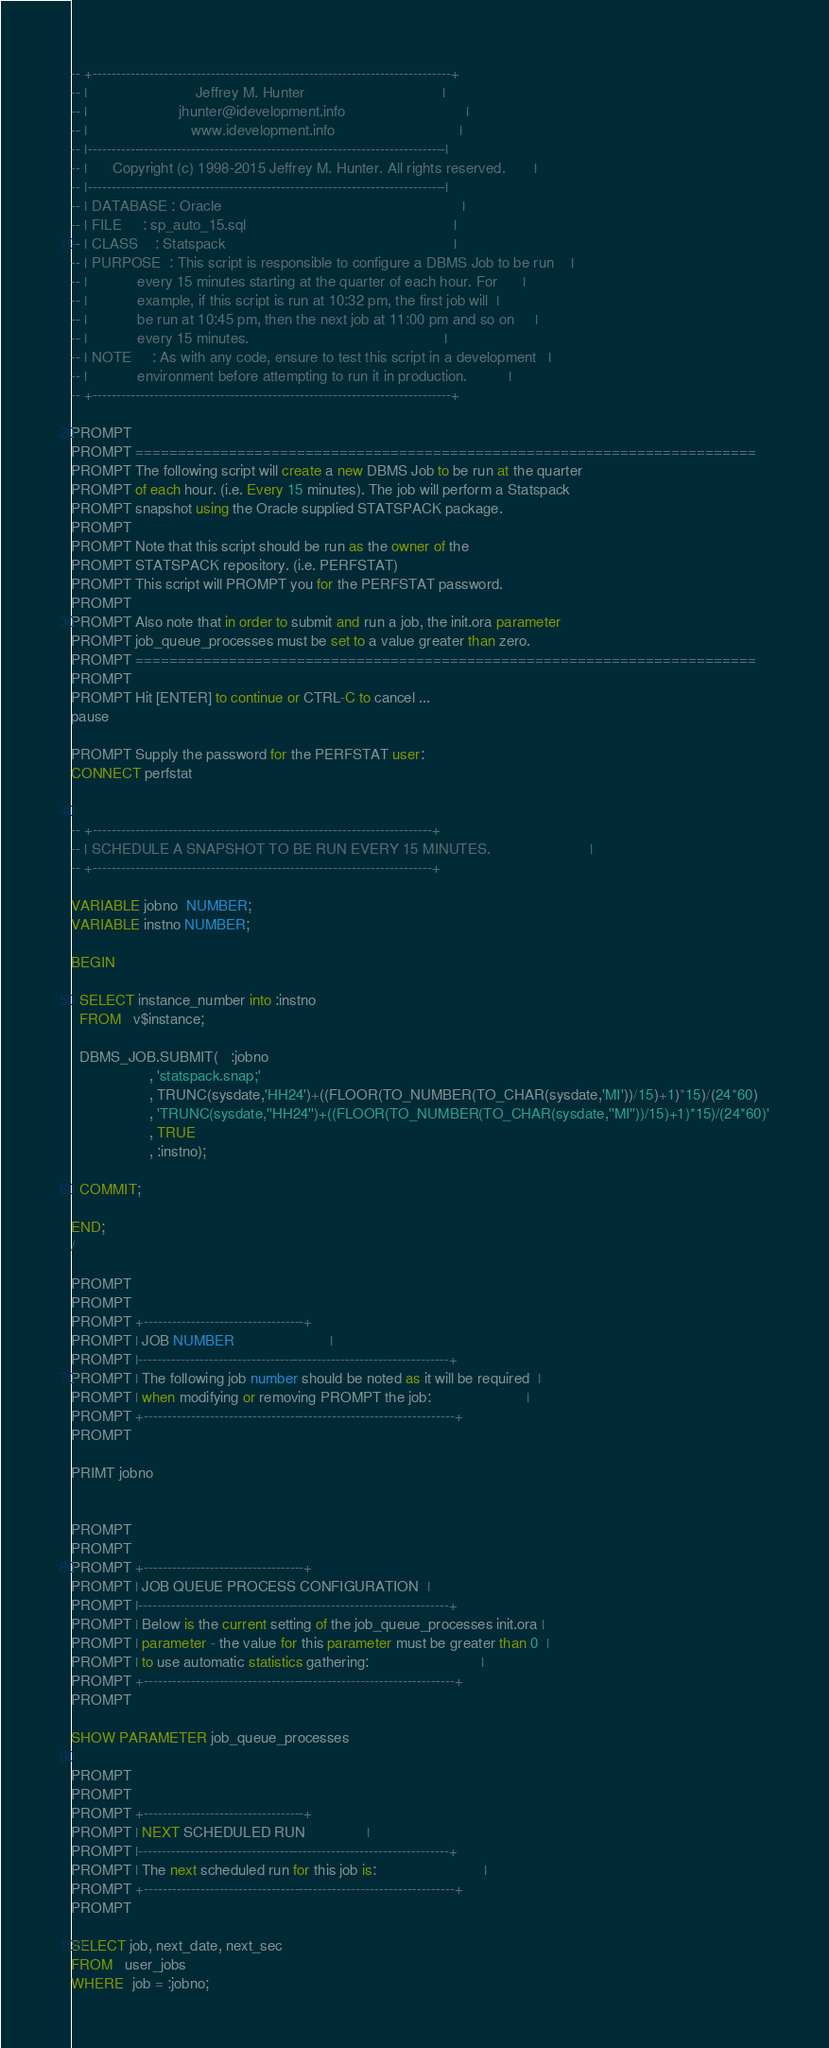<code> <loc_0><loc_0><loc_500><loc_500><_SQL_>-- +----------------------------------------------------------------------------+
-- |                          Jeffrey M. Hunter                                 |
-- |                      jhunter@idevelopment.info                             |
-- |                         www.idevelopment.info                              |
-- |----------------------------------------------------------------------------|
-- |      Copyright (c) 1998-2015 Jeffrey M. Hunter. All rights reserved.       |
-- |----------------------------------------------------------------------------|
-- | DATABASE : Oracle                                                          |
-- | FILE     : sp_auto_15.sql                                                  |
-- | CLASS    : Statspack                                                       |
-- | PURPOSE  : This script is responsible to configure a DBMS Job to be run    |
-- |            every 15 minutes starting at the quarter of each hour. For      |
-- |            example, if this script is run at 10:32 pm, the first job will  |
-- |            be run at 10:45 pm, then the next job at 11:00 pm and so on     |
-- |            every 15 minutes.                                               |
-- | NOTE     : As with any code, ensure to test this script in a development   |
-- |            environment before attempting to run it in production.          |
-- +----------------------------------------------------------------------------+

PROMPT 
PROMPT =========================================================================
PROMPT The following script will create a new DBMS Job to be run at the quarter
PROMPT of each hour. (i.e. Every 15 minutes). The job will perform a Statspack
PROMPT snapshot using the Oracle supplied STATSPACK package.
PROMPT 
PROMPT Note that this script should be run as the owner of the 
PROMPT STATSPACK repository. (i.e. PERFSTAT)
PROMPT This script will PROMPT you for the PERFSTAT password.
PROMPT 
PROMPT Also note that in order to submit and run a job, the init.ora parameter
PROMPT job_queue_processes must be set to a value greater than zero.
PROMPT =========================================================================
PROMPT
PROMPT Hit [ENTER] to continue or CTRL-C to cancel ...
pause

PROMPT Supply the password for the PERFSTAT user:
CONNECT perfstat


-- +------------------------------------------------------------------------+
-- | SCHEDULE A SNAPSHOT TO BE RUN EVERY 15 MINUTES.                        |
-- +------------------------------------------------------------------------+

VARIABLE jobno  NUMBER;
VARIABLE instno NUMBER;

BEGIN

  SELECT instance_number into :instno
  FROM   v$instance;

  DBMS_JOB.SUBMIT(   :jobno
                   , 'statspack.snap;'
                   , TRUNC(sysdate,'HH24')+((FLOOR(TO_NUMBER(TO_CHAR(sysdate,'MI'))/15)+1)*15)/(24*60)
                   , 'TRUNC(sysdate,''HH24'')+((FLOOR(TO_NUMBER(TO_CHAR(sysdate,''MI''))/15)+1)*15)/(24*60)'
                   , TRUE
                   , :instno);

  COMMIT;

END;
/

PROMPT 
PROMPT 
PROMPT +----------------------------------+
PROMPT | JOB NUMBER                       |
PROMPT |------------------------------------------------------------------+
PROMPT | The following job number should be noted as it will be required  |
PROMPT | when modifying or removing PROMPT the job:                       |
PROMPT +------------------------------------------------------------------+
PROMPT 

PRIMT jobno


PROMPT 
PROMPT 
PROMPT +----------------------------------+
PROMPT | JOB QUEUE PROCESS CONFIGURATION  |
PROMPT |------------------------------------------------------------------+
PROMPT | Below is the current setting of the job_queue_processes init.ora |
PROMPT | parameter - the value for this parameter must be greater than 0  |
PROMPT | to use automatic statistics gathering:                           |
PROMPT +------------------------------------------------------------------+
PROMPT 

SHOW PARAMETER job_queue_processes

PROMPT 
PROMPT 
PROMPT +----------------------------------+
PROMPT | NEXT SCHEDULED RUN               |
PROMPT |------------------------------------------------------------------+
PROMPT | The next scheduled run for this job is:                          |
PROMPT +------------------------------------------------------------------+
PROMPT 

SELECT job, next_date, next_sec
FROM   user_jobs
WHERE  job = :jobno;

</code> 